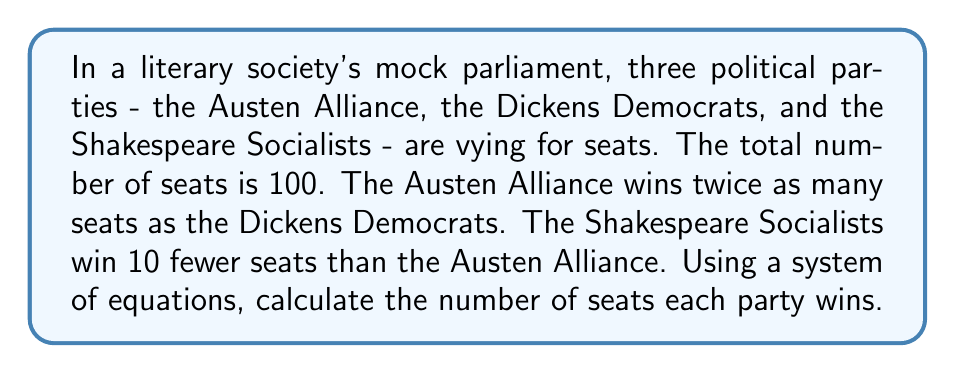Provide a solution to this math problem. Let's approach this step-by-step:

1) Define variables:
   Let $a$ = number of seats for Austen Alliance
   Let $d$ = number of seats for Dickens Democrats
   Let $s$ = number of seats for Shakespeare Socialists

2) Set up equations based on the given information:
   - Total seats: $a + d + s = 100$
   - Austen Alliance wins twice as many as Dickens Democrats: $a = 2d$
   - Shakespeare Socialists win 10 fewer than Austen Alliance: $s = a - 10$

3) Substitute $a = 2d$ and $s = a - 10$ into the total seats equation:
   $2d + d + (2d - 10) = 100$

4) Simplify:
   $5d - 10 = 100$

5) Solve for $d$:
   $5d = 110$
   $d = 22$

6) Calculate $a$ and $s$:
   $a = 2d = 2(22) = 44$
   $s = a - 10 = 44 - 10 = 34$

7) Verify:
   $a + d + s = 44 + 22 + 34 = 100$

Therefore, the Austen Alliance wins 44 seats, the Dickens Democrats win 22 seats, and the Shakespeare Socialists win 34 seats.
Answer: Austen Alliance: 44 seats, Dickens Democrats: 22 seats, Shakespeare Socialists: 34 seats 